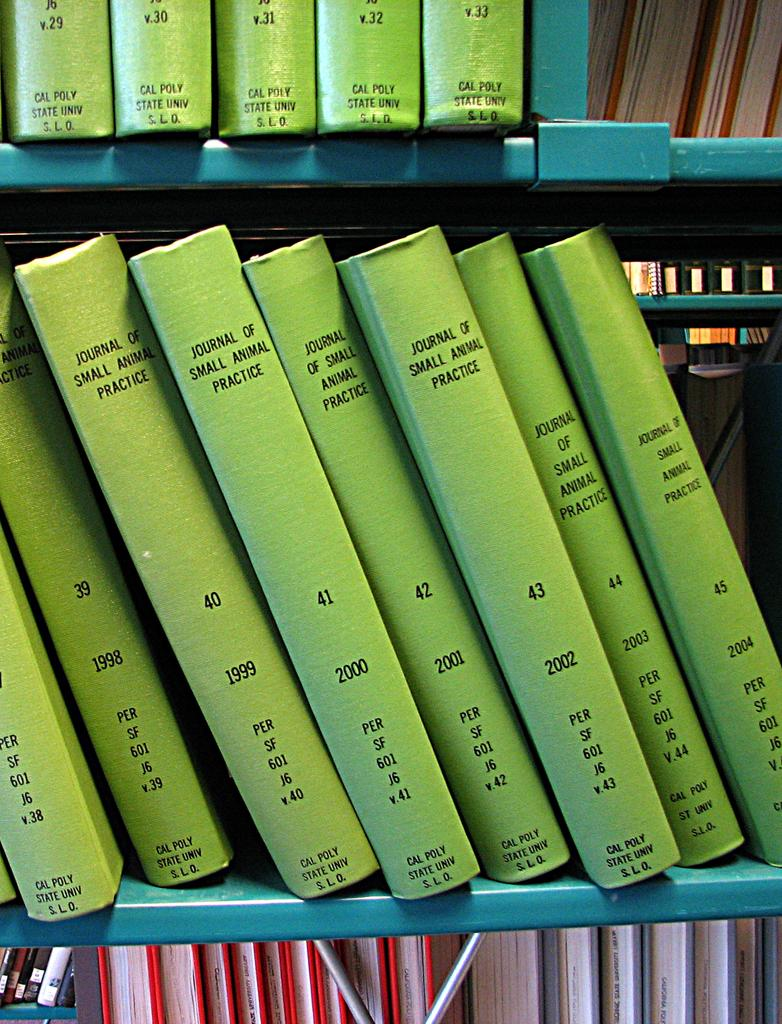<image>
Write a terse but informative summary of the picture. Several volumes of the Journal of Small Animal Practice, all with green spines. 